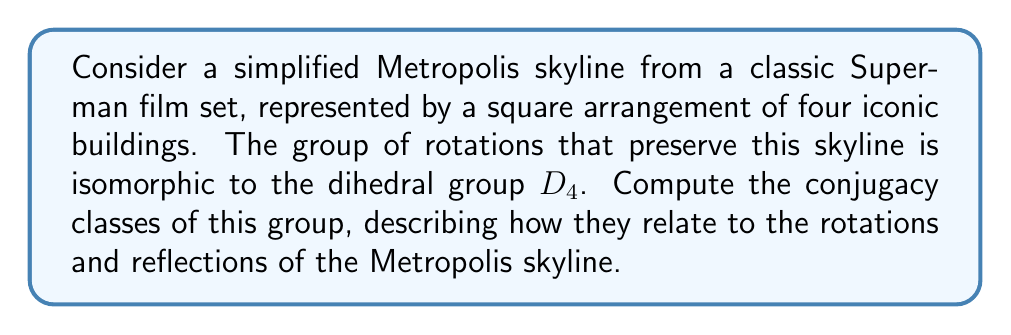Give your solution to this math problem. Let's approach this step-by-step:

1) The dihedral group $D_4$ has 8 elements:
   - Identity: $e$
   - Rotations: $r$ (90°), $r^2$ (180°), $r^3$ (270°)
   - Reflections: $s$, $sr$, $sr^2$, $sr^3$

2) To find conjugacy classes, we need to compute $gxg^{-1}$ for all $g,x \in D_4$.

3) First, let's consider the rotations:
   - $e$ is always in its own conjugacy class: $\{e\}$
   - $r$ and $r^3$ are conjugate to each other:
     $srs = r^3$, $sr^3s = r$
   - $r^2$ is conjugate only to itself

4) Now for the reflections:
   - $s$ and $sr^2$ are conjugate:
     $rsr^{-1} = sr^2$, $r^3sr^{-3} = sr^2$
   - $sr$ and $sr^3$ are conjugate:
     $rsr = sr^3$, $r^3sr^3 = sr$

5) Therefore, we have five conjugacy classes:
   $$\{e\}, \{r,r^3\}, \{r^2\}, \{s,sr^2\}, \{sr,sr^3\}$$

6) Interpreting these in terms of the Metropolis skyline:
   - $\{e\}$: No change to the skyline
   - $\{r,r^3\}$: 90° or 270° rotations
   - $\{r^2\}$: 180° rotation
   - $\{s,sr^2\}$: Reflections across diagonals
   - $\{sr,sr^3\}$: Reflections across vertical/horizontal axes

[asy]
unitsize(30);
draw((-2,-2)--(2,-2)--(2,2)--(-2,2)--cycle);
draw((-1,-2)--(-1,2));
draw((1,-2)--(1,2));
draw((-2,-1)--(2,-1));
draw((-2,1)--(2,1));
label("A", (-1.5,-1.5));
label("B", (1.5,-1.5));
label("C", (1.5,1.5));
label("D", (-1.5,1.5));
[/asy]
Answer: $\{e\}, \{r,r^3\}, \{r^2\}, \{s,sr^2\}, \{sr,sr^3\}$ 